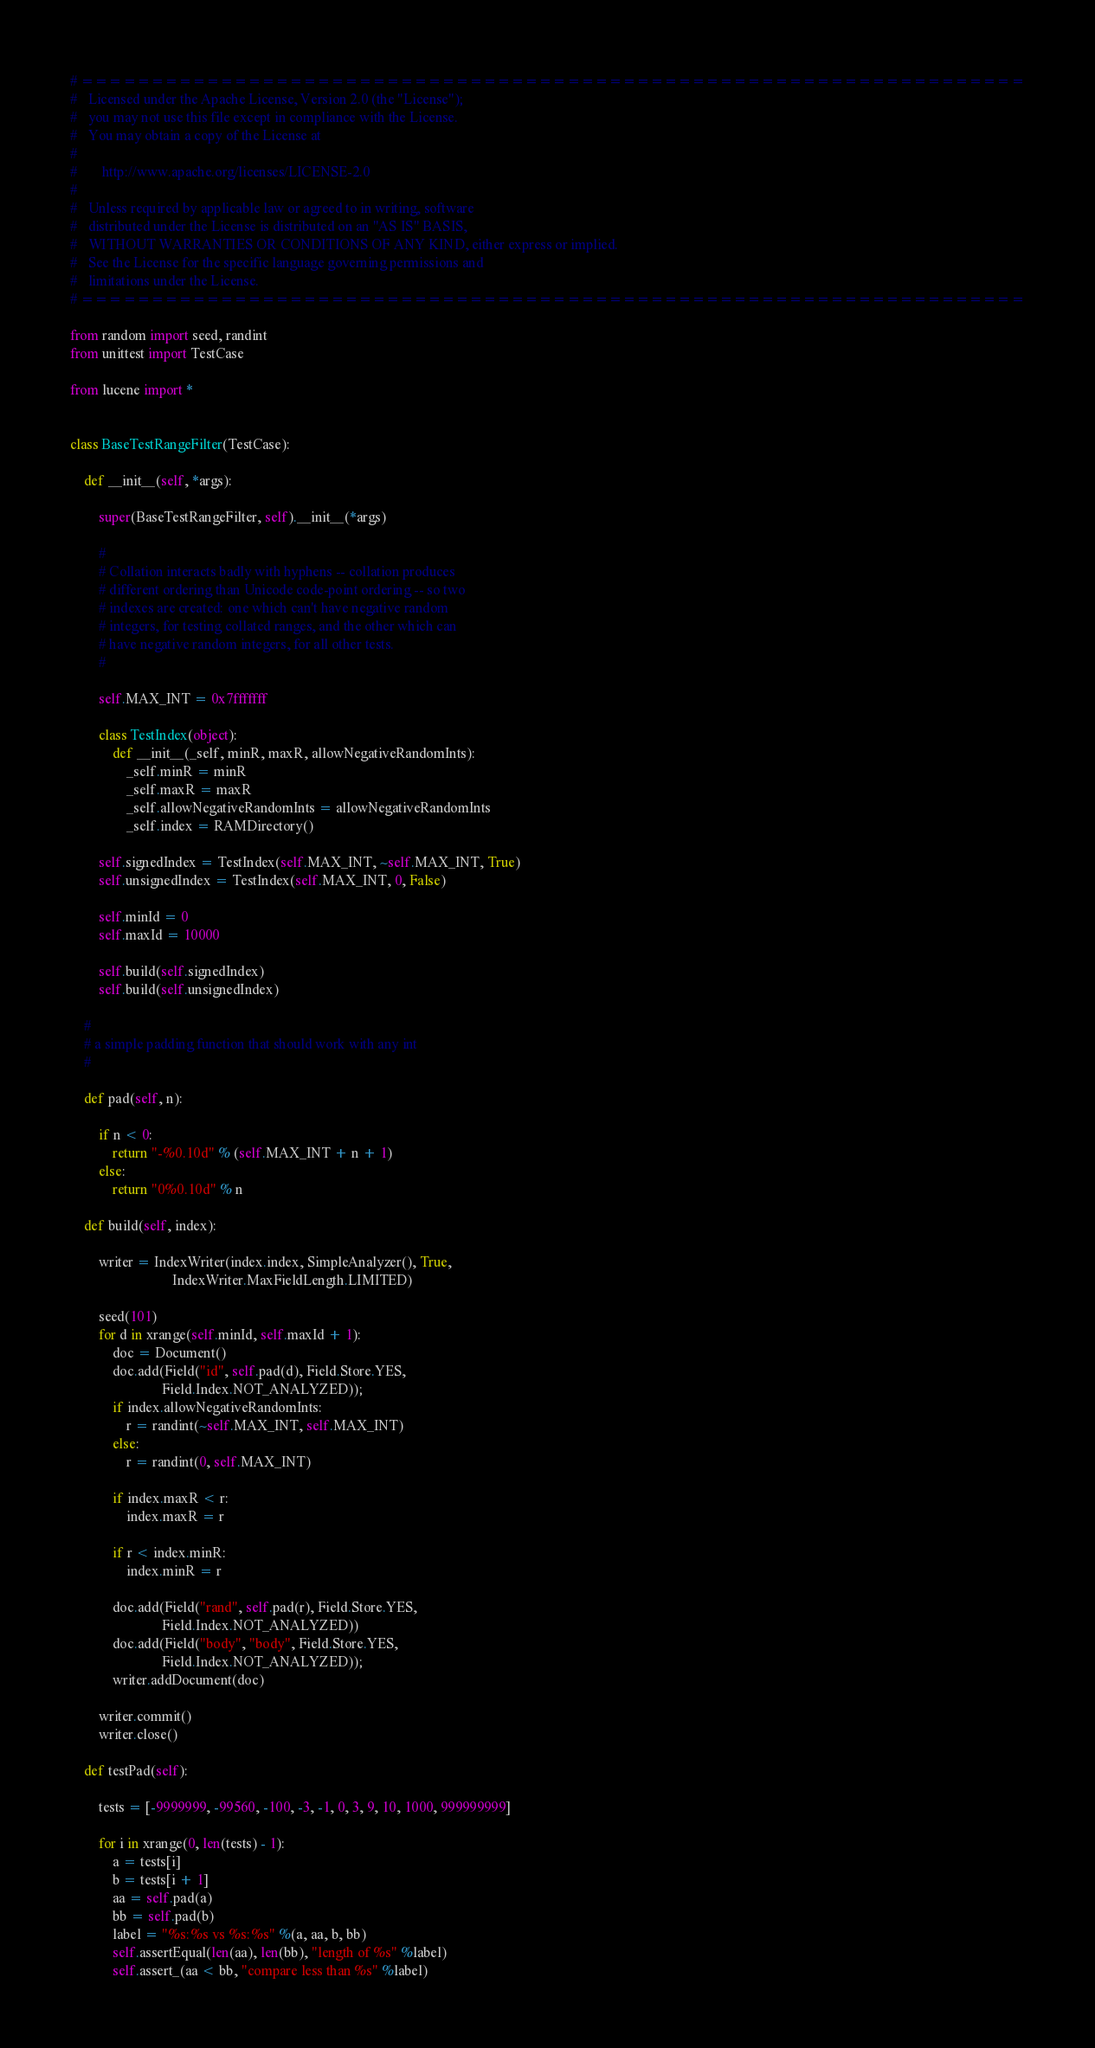Convert code to text. <code><loc_0><loc_0><loc_500><loc_500><_Python_># ====================================================================
#   Licensed under the Apache License, Version 2.0 (the "License");
#   you may not use this file except in compliance with the License.
#   You may obtain a copy of the License at
#
#       http://www.apache.org/licenses/LICENSE-2.0
#
#   Unless required by applicable law or agreed to in writing, software
#   distributed under the License is distributed on an "AS IS" BASIS,
#   WITHOUT WARRANTIES OR CONDITIONS OF ANY KIND, either express or implied.
#   See the License for the specific language governing permissions and
#   limitations under the License.
# ====================================================================

from random import seed, randint
from unittest import TestCase

from lucene import *


class BaseTestRangeFilter(TestCase):

    def __init__(self, *args):

        super(BaseTestRangeFilter, self).__init__(*args)

        # 
        # Collation interacts badly with hyphens -- collation produces
        # different ordering than Unicode code-point ordering -- so two
        # indexes are created: one which can't have negative random
        # integers, for testing collated ranges, and the other which can
        # have negative random integers, for all other tests.
        #

        self.MAX_INT = 0x7fffffff

        class TestIndex(object):
            def __init__(_self, minR, maxR, allowNegativeRandomInts):
                _self.minR = minR
                _self.maxR = maxR
                _self.allowNegativeRandomInts = allowNegativeRandomInts
                _self.index = RAMDirectory()

        self.signedIndex = TestIndex(self.MAX_INT, ~self.MAX_INT, True)
        self.unsignedIndex = TestIndex(self.MAX_INT, 0, False)

        self.minId = 0
        self.maxId = 10000

        self.build(self.signedIndex)
        self.build(self.unsignedIndex)

    #
    # a simple padding function that should work with any int
    #

    def pad(self, n):

        if n < 0:
            return "-%0.10d" % (self.MAX_INT + n + 1)
        else:
            return "0%0.10d" % n

    def build(self, index):

        writer = IndexWriter(index.index, SimpleAnalyzer(), True, 
                             IndexWriter.MaxFieldLength.LIMITED)

        seed(101)
        for d in xrange(self.minId, self.maxId + 1):
            doc = Document()
            doc.add(Field("id", self.pad(d), Field.Store.YES,
                          Field.Index.NOT_ANALYZED));
            if index.allowNegativeRandomInts:
                r = randint(~self.MAX_INT, self.MAX_INT)
            else:
                r = randint(0, self.MAX_INT)

            if index.maxR < r:
                index.maxR = r

            if r < index.minR:
                index.minR = r

            doc.add(Field("rand", self.pad(r), Field.Store.YES,
                          Field.Index.NOT_ANALYZED))
            doc.add(Field("body", "body", Field.Store.YES,
                          Field.Index.NOT_ANALYZED));
            writer.addDocument(doc)
            
        writer.commit()
        writer.close()

    def testPad(self):

        tests = [-9999999, -99560, -100, -3, -1, 0, 3, 9, 10, 1000, 999999999]

        for i in xrange(0, len(tests) - 1):
            a = tests[i]
            b = tests[i + 1]
            aa = self.pad(a)
            bb = self.pad(b)
            label = "%s:%s vs %s:%s" %(a, aa, b, bb)
            self.assertEqual(len(aa), len(bb), "length of %s" %label)
            self.assert_(aa < bb, "compare less than %s" %label)

</code> 